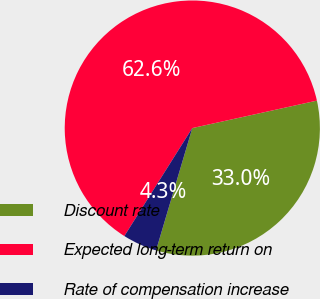Convert chart to OTSL. <chart><loc_0><loc_0><loc_500><loc_500><pie_chart><fcel>Discount rate<fcel>Expected long-term return on<fcel>Rate of compensation increase<nl><fcel>33.04%<fcel>62.61%<fcel>4.35%<nl></chart> 